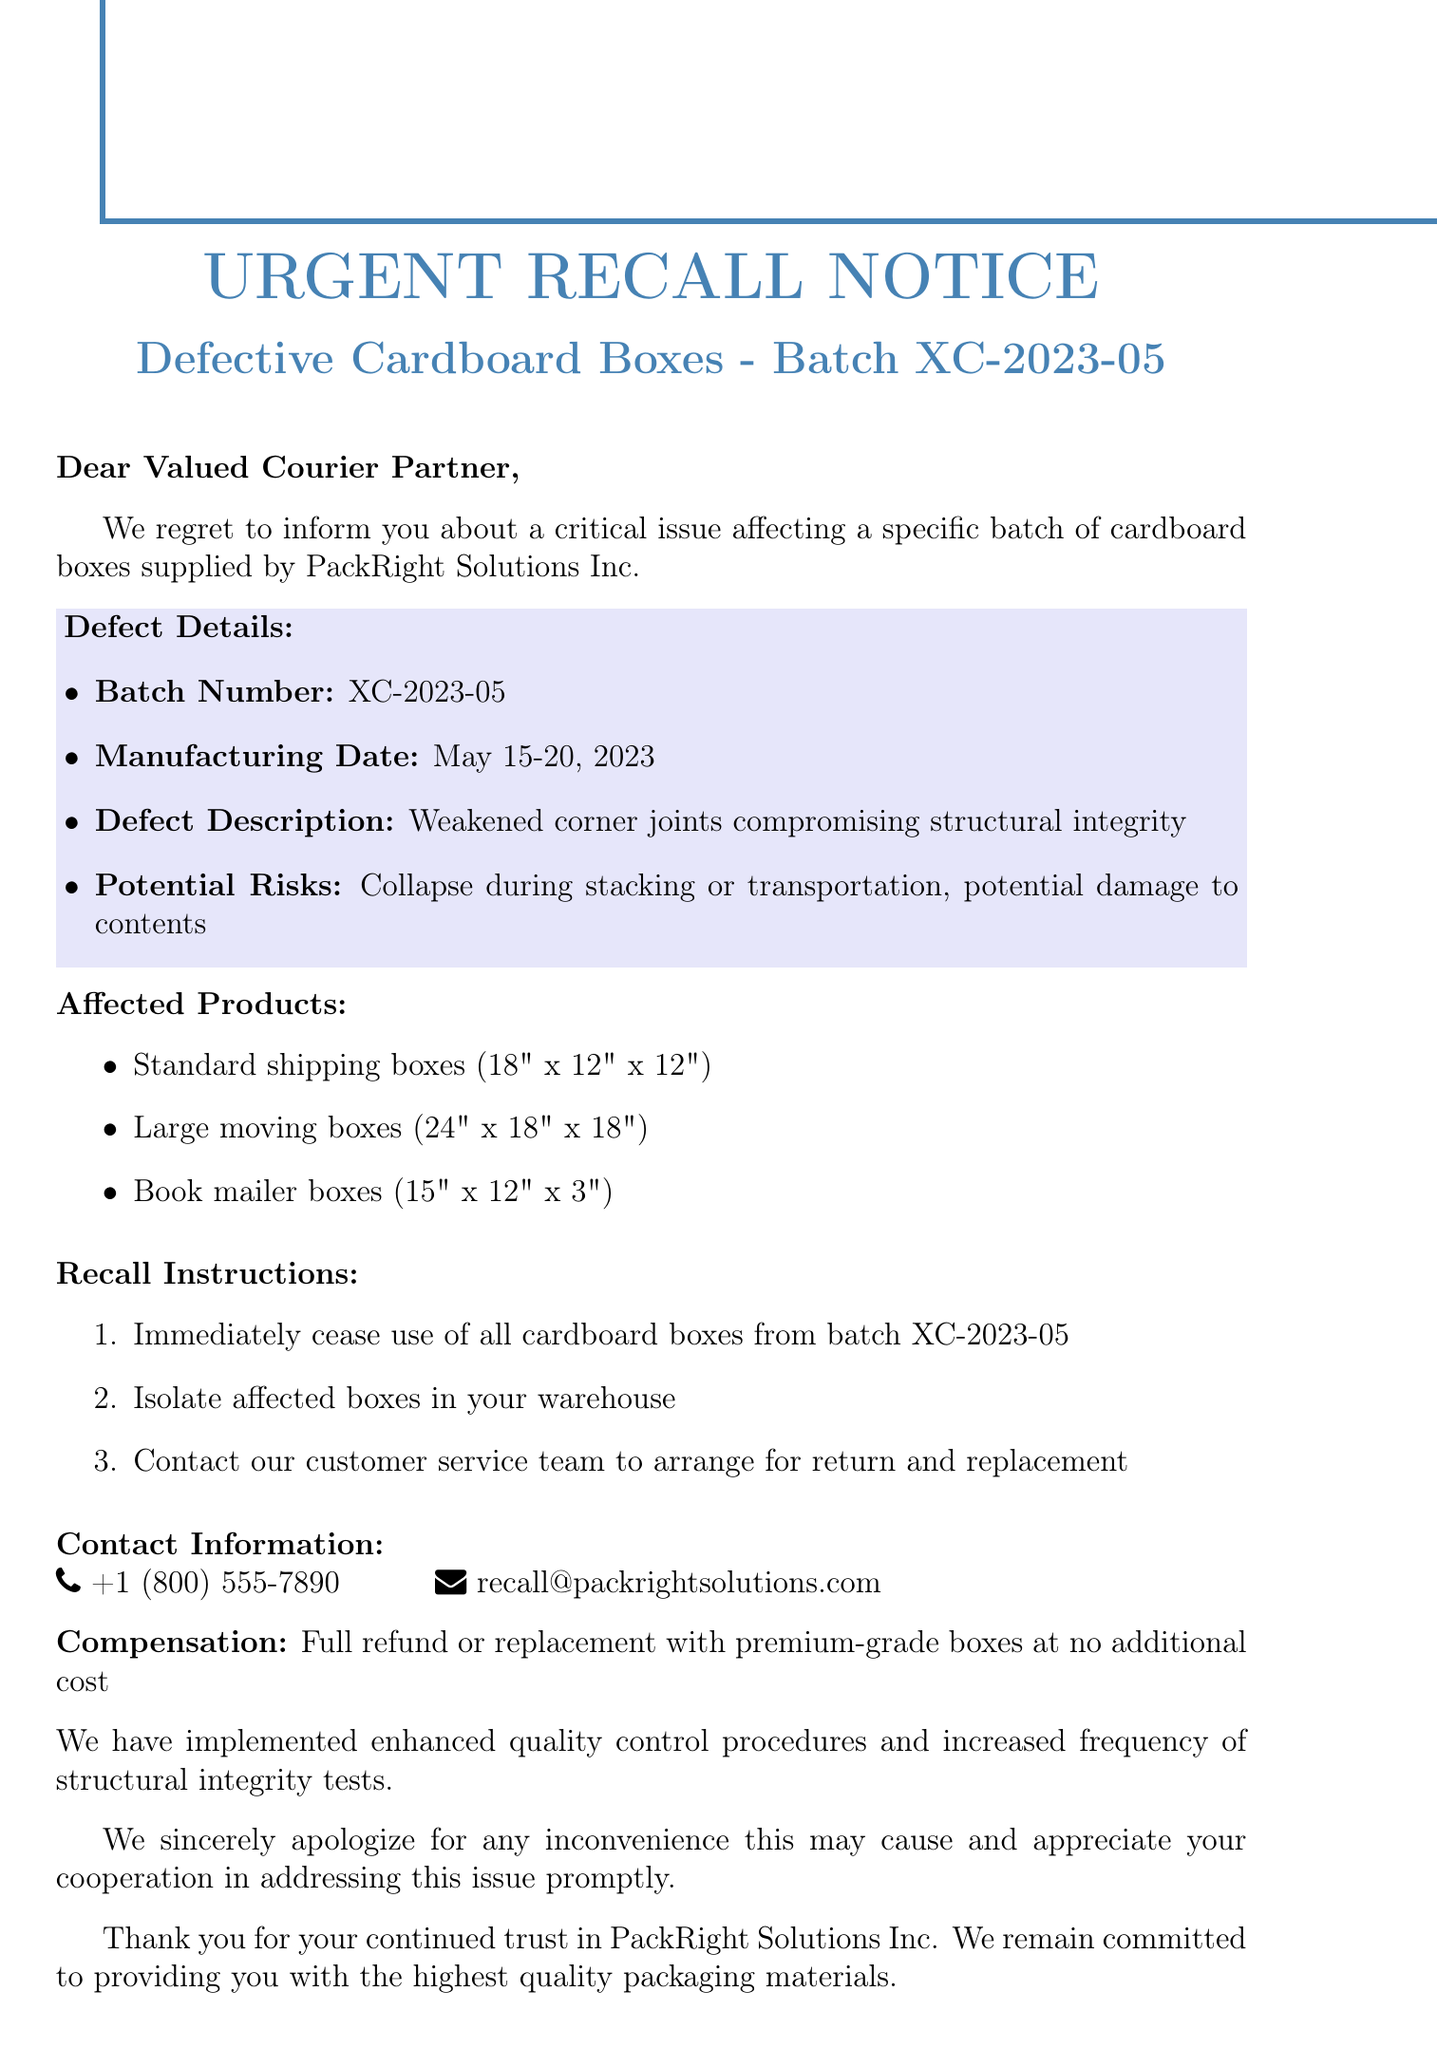What is the subject of the recall notice? The subject provides the main topic of the email, which is a recall notice for a specific batch of products.
Answer: Urgent Recall Notice: Defective Cardboard Boxes - Batch XC-2023-05 What is the batch number being recalled? The batch number is a specific identifier for the products affected by the recall.
Answer: XC-2023-05 What is the manufacturing date range of the affected boxes? The manufacturing date provides the time frame during which the defective boxes were produced.
Answer: May 15-20, 2023 What are the potential risks associated with the defective boxes? This details the consequences of using the affected products, giving insight into safety concerns.
Answer: Collapse during stacking or transportation, potential damage to contents What is the compensation offered for the recall? The compensation outlines what the company is providing to the partners affected by the recall.
Answer: Full refund or replacement with premium-grade boxes at no additional cost What should be done with the affected boxes? This instructs the courier partner on the immediate action needed regarding the recalled products.
Answer: Isolate affected boxes in your warehouse Who is the sender of the recall notice? The sender's information indicates who is responsible for this communication and can provide credibility.
Answer: James Thompson What position does the sender hold? Understanding the sender's position can provide context about their authority and responsibility within the company.
Answer: Quality Assurance Manager How can the customer service be contacted? Knowing how to reach customer service is essential for handling the recall process efficiently.
Answer: +1 (800) 555-7890 or recall@packrightsolutions.com 